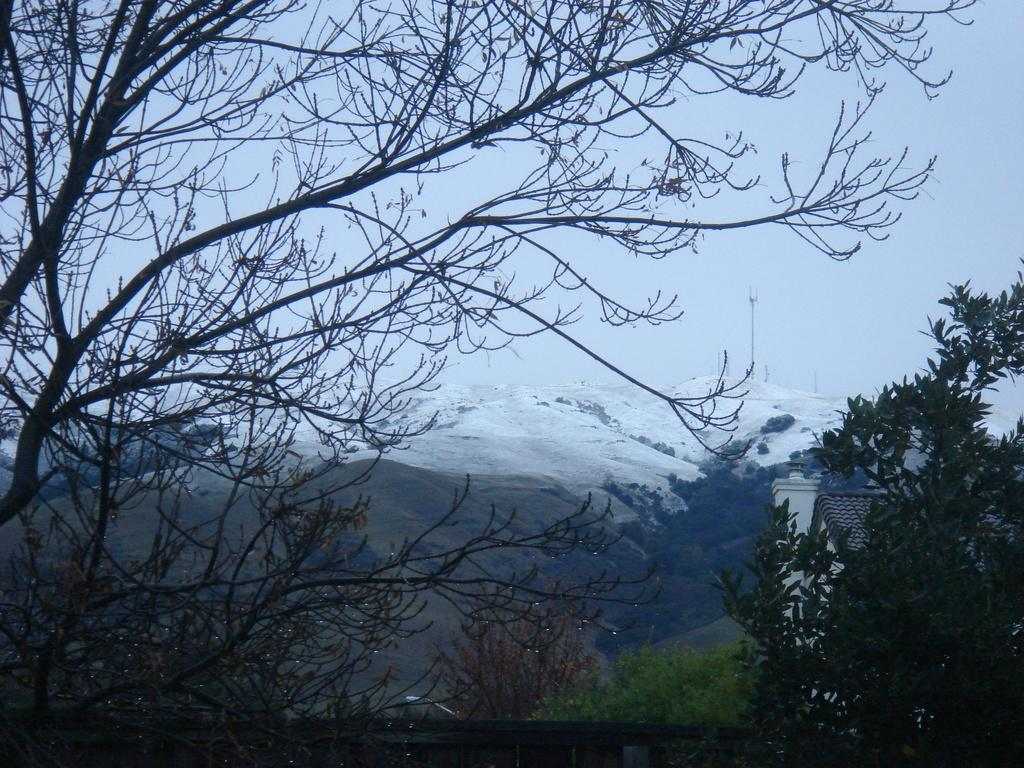What type of natural features can be seen in the image? There are trees and mountains with snow in the image. What is the condition of the sky in the image? The sky is cloudy in the image. What type of advertisement can be seen on the trees in the image? There are no advertisements present on the trees in the image; it features natural scenery. What knowledge can be gained from the image about the local climate? The presence of snow on the mountains and cloudy sky suggest a cold climate, but the image does not provide specific information about the local climate. 